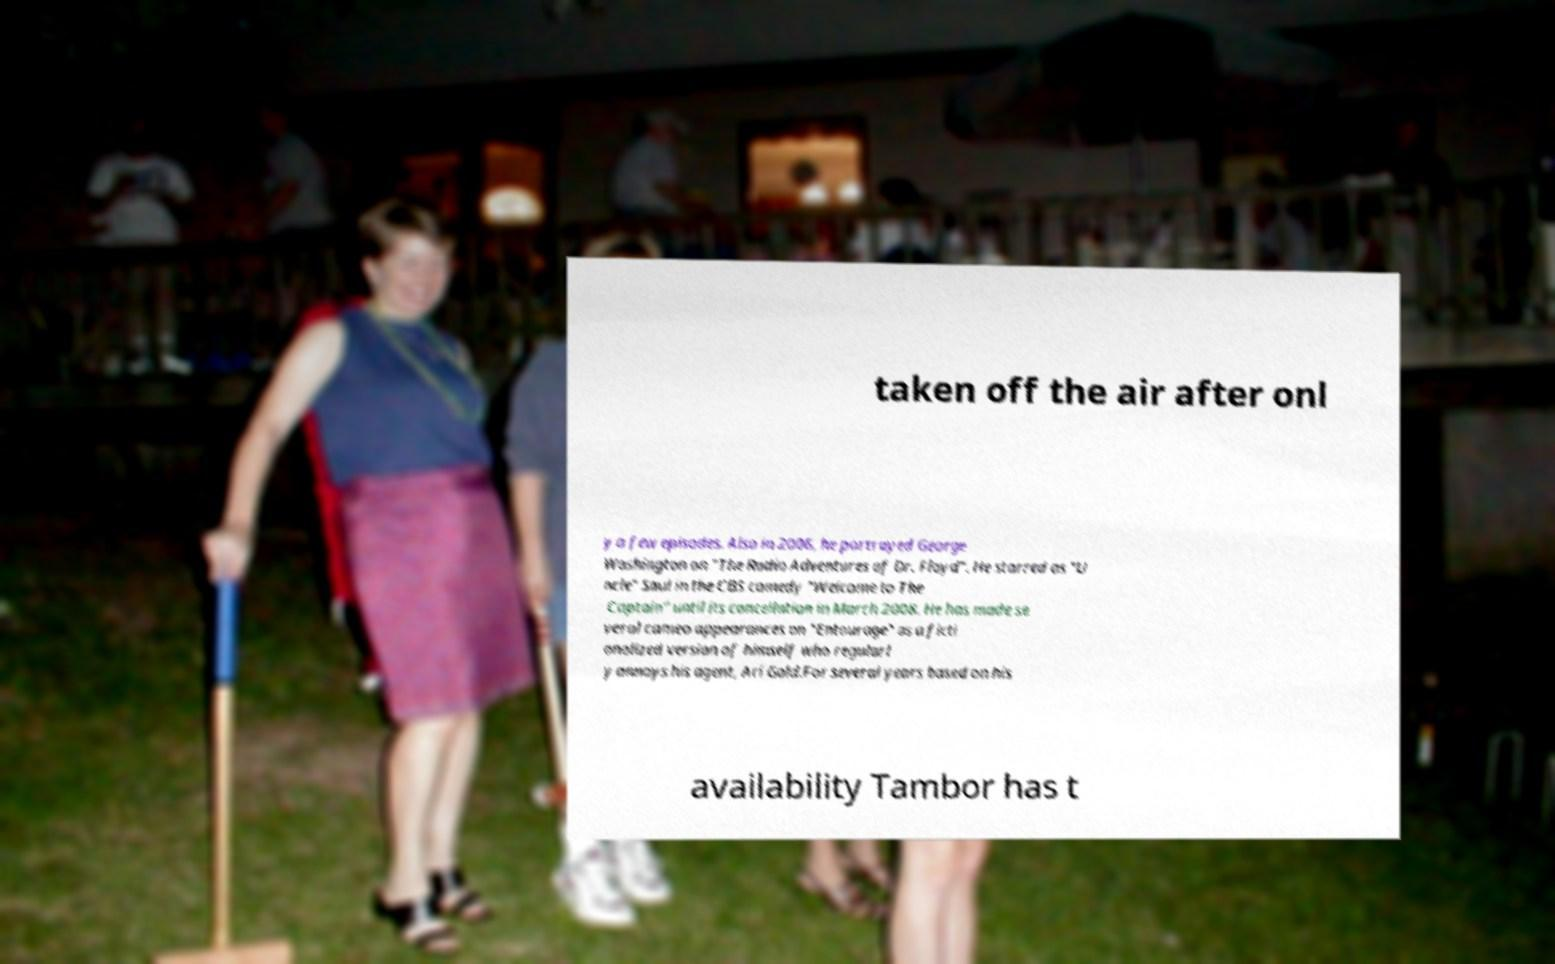Could you extract and type out the text from this image? taken off the air after onl y a few episodes. Also in 2006, he portrayed George Washington on "The Radio Adventures of Dr. Floyd". He starred as "U ncle" Saul in the CBS comedy "Welcome to The Captain" until its cancellation in March 2008. He has made se veral cameo appearances on "Entourage" as a ficti onalized version of himself who regularl y annoys his agent, Ari Gold.For several years based on his availability Tambor has t 